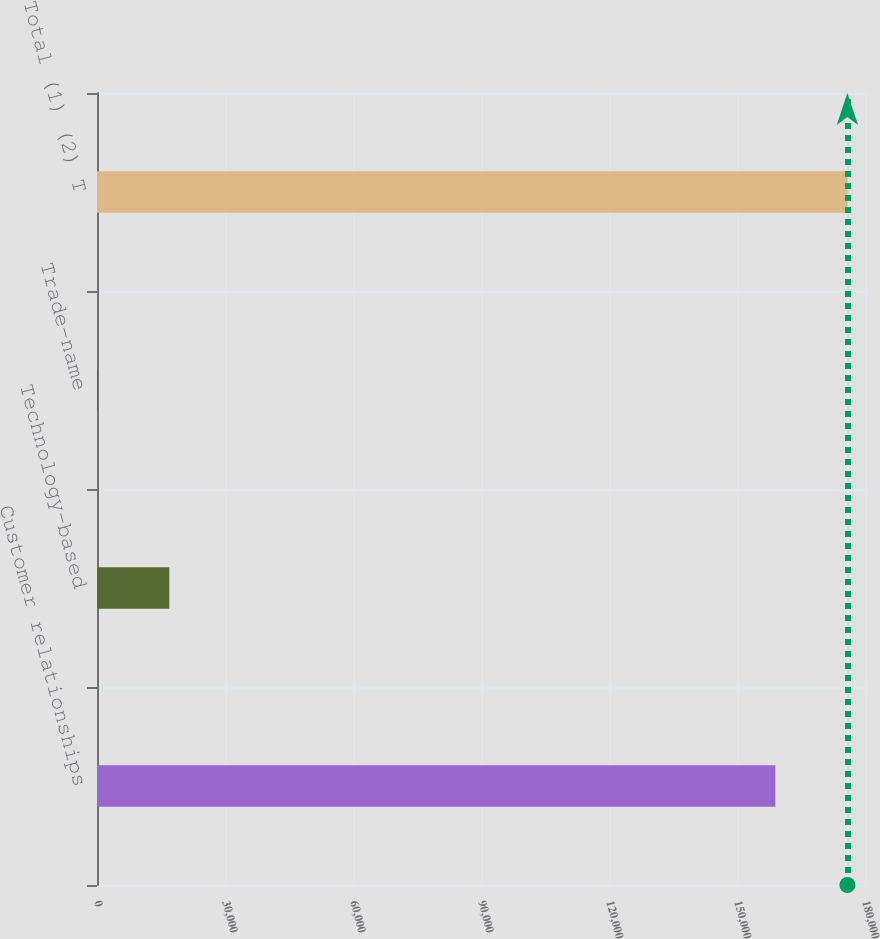Convert chart to OTSL. <chart><loc_0><loc_0><loc_500><loc_500><bar_chart><fcel>Customer relationships<fcel>Technology-based<fcel>Trade-name<fcel>Total (1) (2) T<nl><fcel>158979<fcel>16953.7<fcel>60<fcel>175873<nl></chart> 